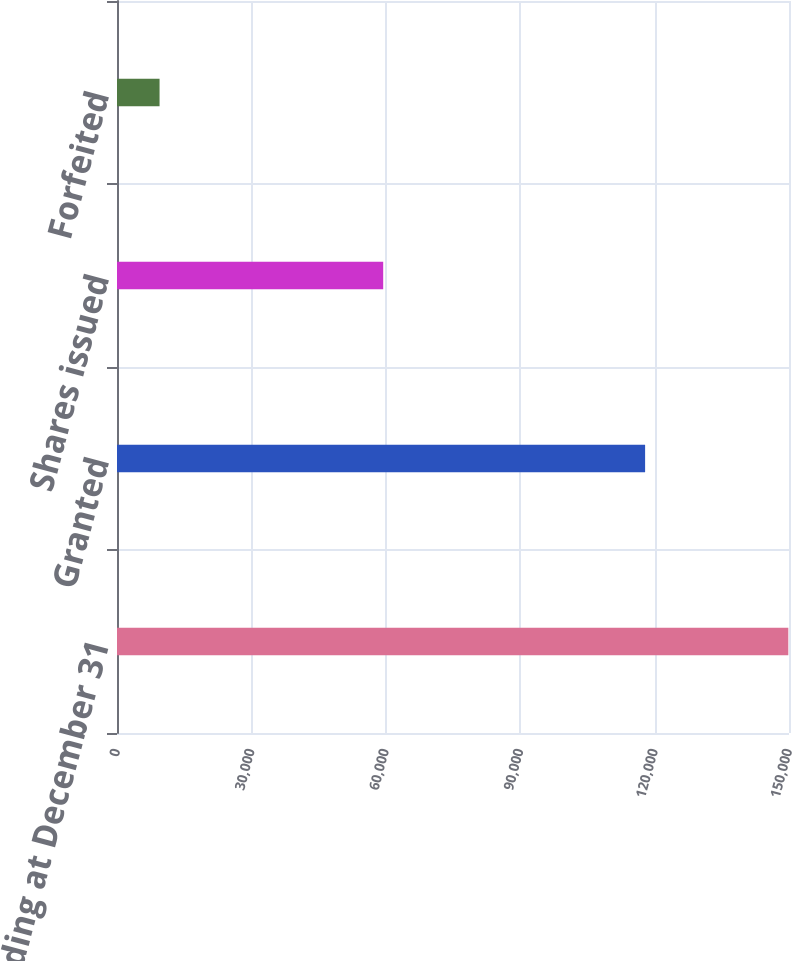Convert chart. <chart><loc_0><loc_0><loc_500><loc_500><bar_chart><fcel>Outstanding at December 31<fcel>Granted<fcel>Shares issued<fcel>Forfeited<nl><fcel>149847<fcel>117881<fcel>59418<fcel>9500<nl></chart> 